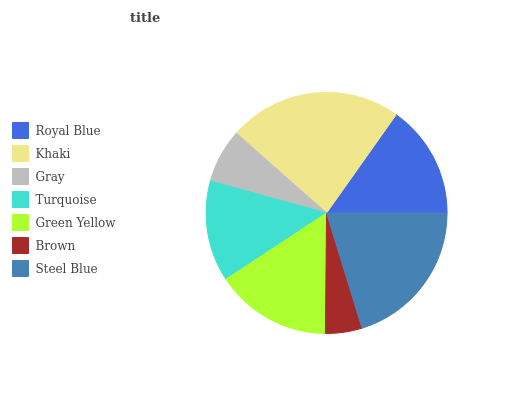Is Brown the minimum?
Answer yes or no. Yes. Is Khaki the maximum?
Answer yes or no. Yes. Is Gray the minimum?
Answer yes or no. No. Is Gray the maximum?
Answer yes or no. No. Is Khaki greater than Gray?
Answer yes or no. Yes. Is Gray less than Khaki?
Answer yes or no. Yes. Is Gray greater than Khaki?
Answer yes or no. No. Is Khaki less than Gray?
Answer yes or no. No. Is Royal Blue the high median?
Answer yes or no. Yes. Is Royal Blue the low median?
Answer yes or no. Yes. Is Brown the high median?
Answer yes or no. No. Is Khaki the low median?
Answer yes or no. No. 